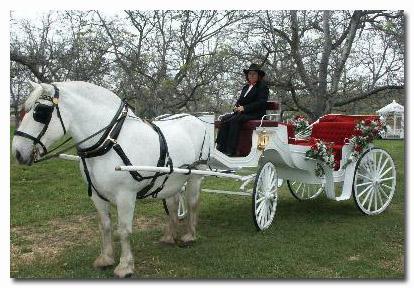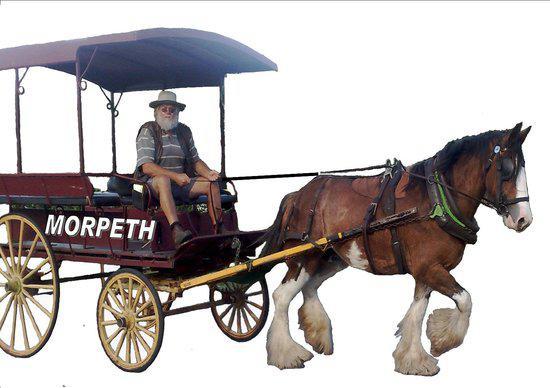The first image is the image on the left, the second image is the image on the right. Analyze the images presented: Is the assertion "The horse drawn carriage in the image on the right is against a plain white background." valid? Answer yes or no. Yes. The first image is the image on the left, the second image is the image on the right. Assess this claim about the two images: "There is a carriage hitched to a pair of white horses.". Correct or not? Answer yes or no. No. 